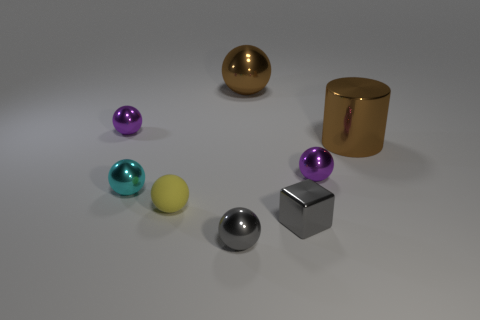Is there anything else that is made of the same material as the tiny yellow object?
Ensure brevity in your answer.  No. There is a rubber sphere; does it have the same color as the tiny metal ball in front of the small cyan metal object?
Offer a terse response. No. What shape is the tiny metal thing that is on the right side of the large sphere and in front of the cyan ball?
Your response must be concise. Cube. What number of yellow matte objects are there?
Provide a succinct answer. 1. There is a object that is the same color as the metallic cylinder; what shape is it?
Your answer should be compact. Sphere. What is the size of the brown object that is the same shape as the yellow thing?
Provide a succinct answer. Large. There is a purple metallic thing on the right side of the small matte thing; does it have the same shape as the matte object?
Make the answer very short. Yes. There is a thing left of the cyan sphere; what is its color?
Provide a succinct answer. Purple. How many other objects are there of the same size as the brown ball?
Give a very brief answer. 1. Are there the same number of cylinders that are to the left of the gray sphere and tiny purple blocks?
Your response must be concise. Yes. 